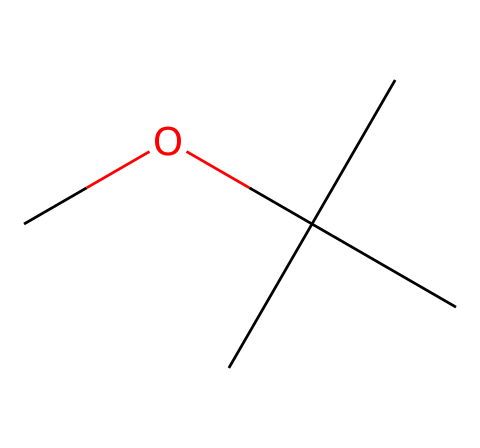What is the molecular formula of methyl tert-butyl ether? To deduce the molecular formula, we can identify the elements in the structure. The structure has one carbon from the methoxy group (O-CH3) and four carbons from the tert-butyl group (C(C)(C)C), giving a total of five carbons. Additionally, there are twelve hydrogens and one oxygen. Thus, we combine them to arrive at the molecular formula C5H12O.
Answer: C5H12O How many carbon atoms are present in methyl tert-butyl ether? By examining the SMILES representation, we can count the carbon atoms. The structure includes one carbon from the methoxy part and four from the tert-butyl part, leading to a total of five carbon atoms.
Answer: 5 What type of chemical compound is methyl tert-butyl ether? Methyl tert-butyl ether contains an ether functional group, defined by the C-O-C structure depicted in the molecule. Thus, it is classified as an ether.
Answer: ether What is the primary use of methyl tert-butyl ether? Methyl tert-butyl ether is primarily used as a gasoline additive to improve octane ratings, which helps reduce engine knocking in vehicles.
Answer: gasoline additive Does methyl tert-butyl ether have environmental implications? Yes, methyl tert-butyl ether has environmental implications, particularly concerning groundwater contamination. Its widespread use in fuels raises concerns about its potential to leach into water supplies.
Answer: Yes 